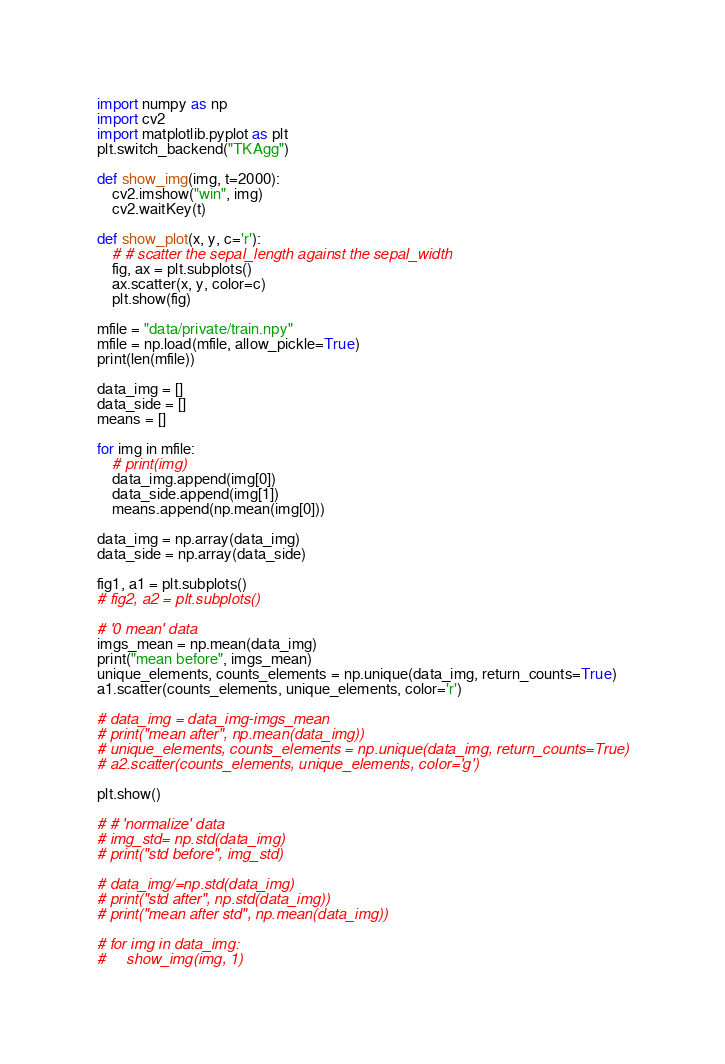<code> <loc_0><loc_0><loc_500><loc_500><_Python_>import numpy as np
import cv2
import matplotlib.pyplot as plt
plt.switch_backend("TKAgg")

def show_img(img, t=2000):
    cv2.imshow("win", img)
    cv2.waitKey(t)
    
def show_plot(x, y, c='r'):
    # # scatter the sepal_length against the sepal_width
    fig, ax = plt.subplots()
    ax.scatter(x, y, color=c)
    plt.show(fig)
    
mfile = "data/private/train.npy"
mfile = np.load(mfile, allow_pickle=True)
print(len(mfile))

data_img = []
data_side = []
means = []

for img in mfile:
    # print(img)
    data_img.append(img[0])
    data_side.append(img[1])
    means.append(np.mean(img[0]))

data_img = np.array(data_img)
data_side = np.array(data_side)

fig1, a1 = plt.subplots()
# fig2, a2 = plt.subplots()

# '0 mean' data
imgs_mean = np.mean(data_img)
print("mean before", imgs_mean)
unique_elements, counts_elements = np.unique(data_img, return_counts=True)
a1.scatter(counts_elements, unique_elements, color='r')

# data_img = data_img-imgs_mean
# print("mean after", np.mean(data_img))
# unique_elements, counts_elements = np.unique(data_img, return_counts=True)
# a2.scatter(counts_elements, unique_elements, color='g')

plt.show()

# # 'normalize' data
# img_std= np.std(data_img)
# print("std before", img_std)

# data_img/=np.std(data_img)
# print("std after", np.std(data_img))
# print("mean after std", np.mean(data_img))

# for img in data_img:
#     show_img(img, 1)

</code> 